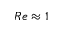Convert formula to latex. <formula><loc_0><loc_0><loc_500><loc_500>R e \approx 1</formula> 